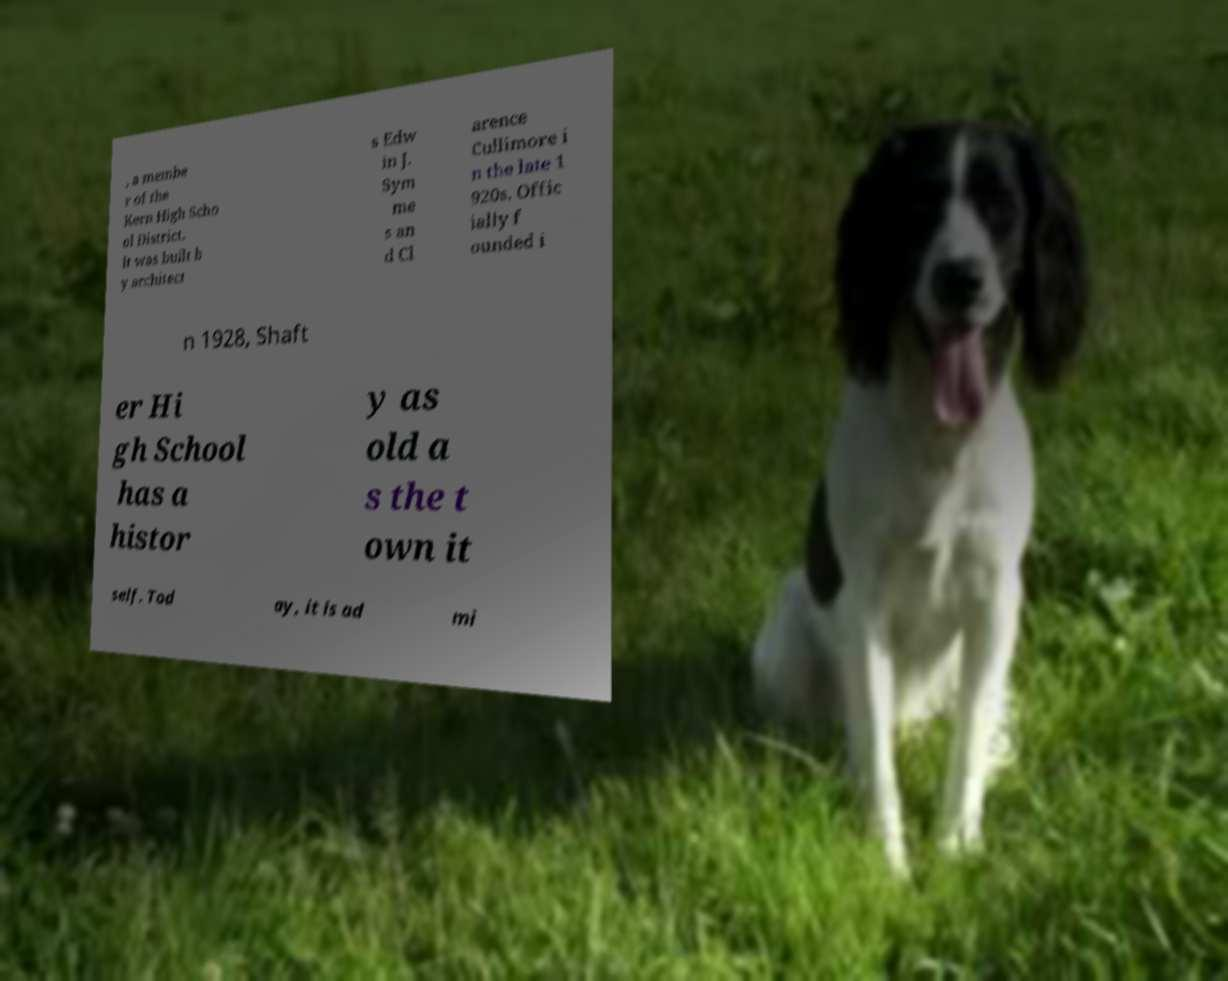For documentation purposes, I need the text within this image transcribed. Could you provide that? , a membe r of the Kern High Scho ol District. It was built b y architect s Edw in J. Sym me s an d Cl arence Cullimore i n the late 1 920s. Offic ially f ounded i n 1928, Shaft er Hi gh School has a histor y as old a s the t own it self. Tod ay, it is ad mi 